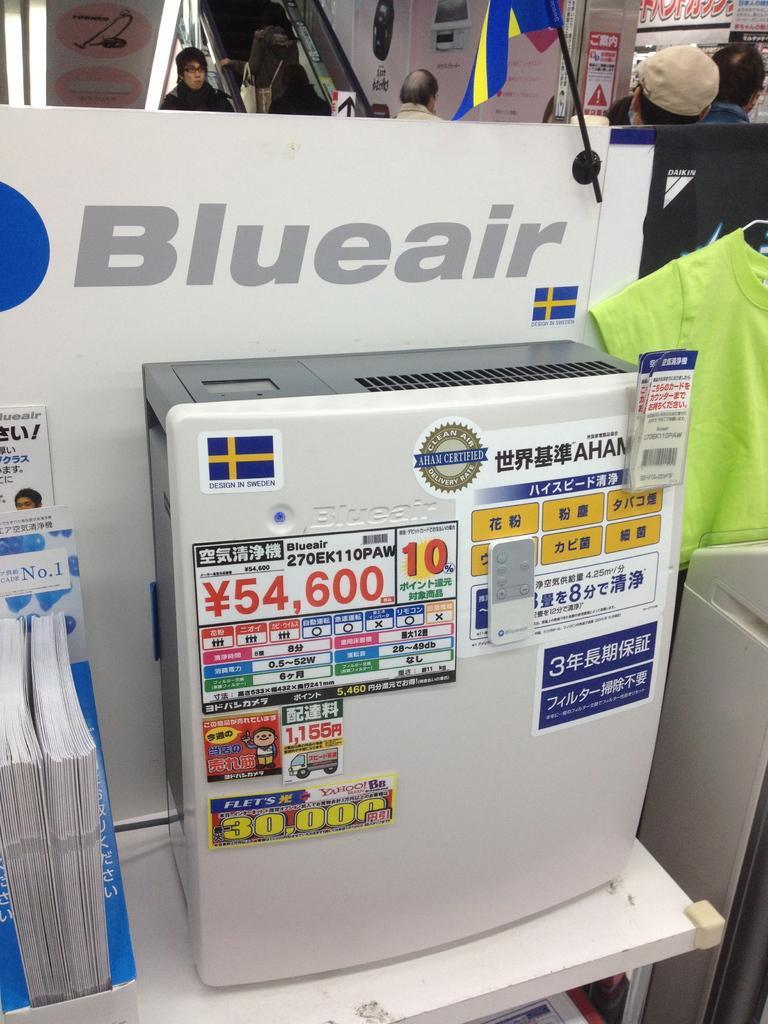Describe this image in one or two sentences. In this image there are people. There are tables. We can see boxes and papers. There is wall with boards in the background. 